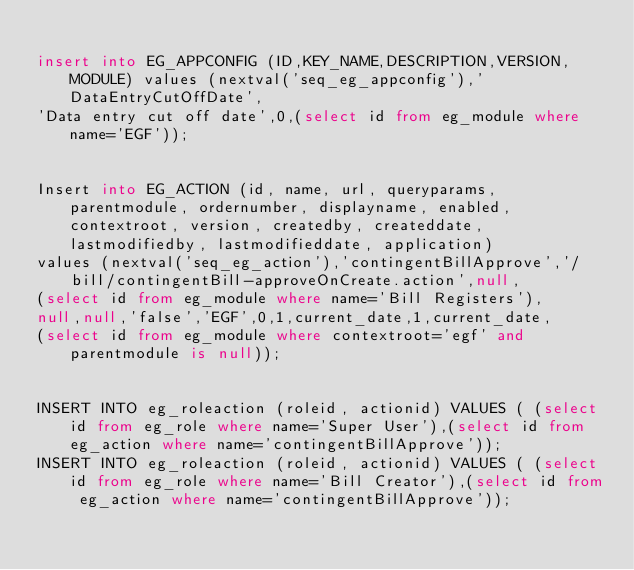Convert code to text. <code><loc_0><loc_0><loc_500><loc_500><_SQL_>
insert into EG_APPCONFIG (ID,KEY_NAME,DESCRIPTION,VERSION,MODULE) values (nextval('seq_eg_appconfig'),'DataEntryCutOffDate',
'Data entry cut off date',0,(select id from eg_module where name='EGF'));


Insert into EG_ACTION (id, name, url, queryparams, parentmodule, ordernumber, displayname, enabled, contextroot, version, createdby, createddate, lastmodifiedby, lastmodifieddate, application) 
values (nextval('seq_eg_action'),'contingentBillApprove','/bill/contingentBill-approveOnCreate.action',null,
(select id from eg_module where name='Bill Registers'),
null,null,'false','EGF',0,1,current_date,1,current_date,
(select id from eg_module where contextroot='egf' and parentmodule is null));


INSERT INTO eg_roleaction (roleid, actionid) VALUES ( (select id from eg_role where name='Super User'),(select id from eg_action where name='contingentBillApprove'));
INSERT INTO eg_roleaction (roleid, actionid) VALUES ( (select id from eg_role where name='Bill Creator'),(select id from eg_action where name='contingentBillApprove'));
</code> 